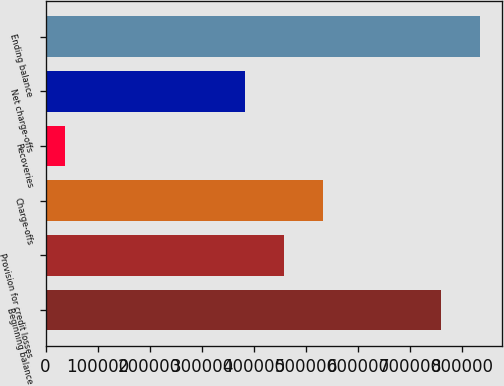Convert chart to OTSL. <chart><loc_0><loc_0><loc_500><loc_500><bar_chart><fcel>Beginning balance<fcel>Provision for credit losses<fcel>Charge-offs<fcel>Recoveries<fcel>Net charge-offs<fcel>Ending balance<nl><fcel>759439<fcel>458036<fcel>533062<fcel>37645<fcel>383010<fcel>834465<nl></chart> 